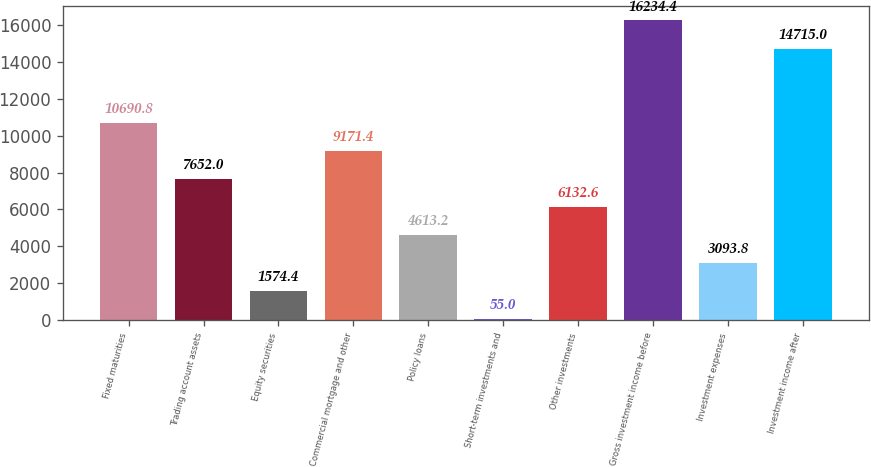Convert chart. <chart><loc_0><loc_0><loc_500><loc_500><bar_chart><fcel>Fixed maturities<fcel>Trading account assets<fcel>Equity securities<fcel>Commercial mortgage and other<fcel>Policy loans<fcel>Short-term investments and<fcel>Other investments<fcel>Gross investment income before<fcel>Investment expenses<fcel>Investment income after<nl><fcel>10690.8<fcel>7652<fcel>1574.4<fcel>9171.4<fcel>4613.2<fcel>55<fcel>6132.6<fcel>16234.4<fcel>3093.8<fcel>14715<nl></chart> 